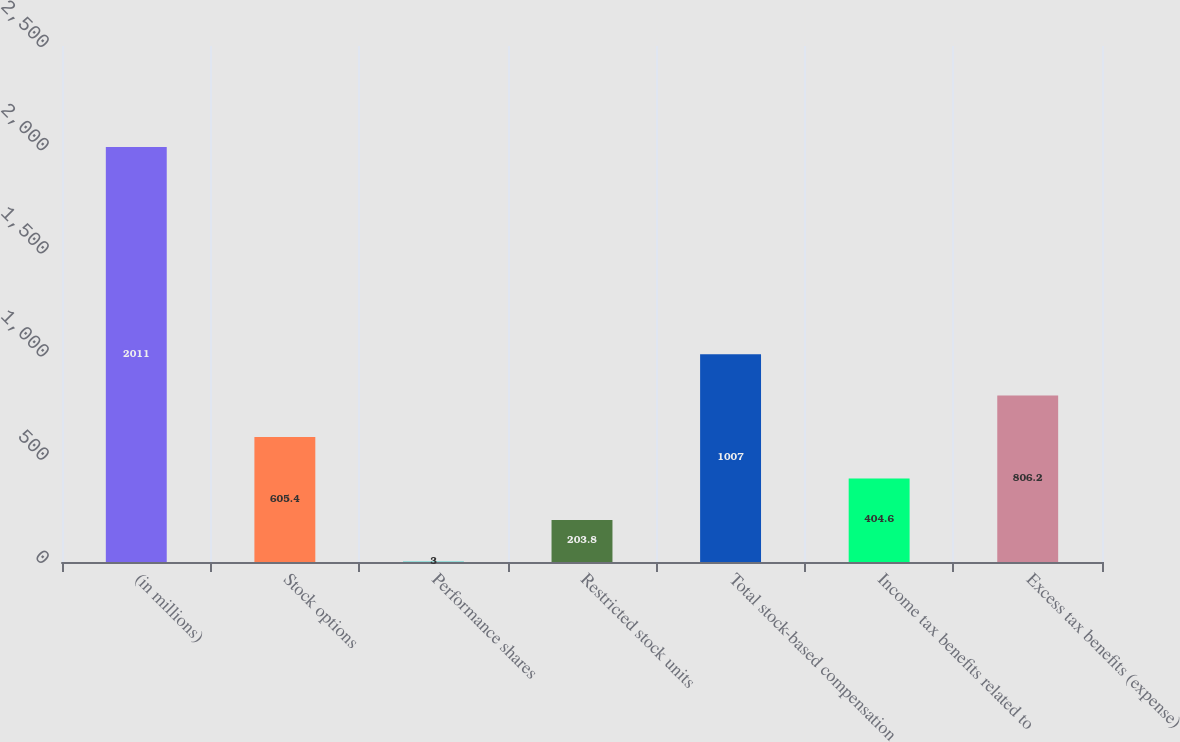<chart> <loc_0><loc_0><loc_500><loc_500><bar_chart><fcel>(in millions)<fcel>Stock options<fcel>Performance shares<fcel>Restricted stock units<fcel>Total stock-based compensation<fcel>Income tax benefits related to<fcel>Excess tax benefits (expense)<nl><fcel>2011<fcel>605.4<fcel>3<fcel>203.8<fcel>1007<fcel>404.6<fcel>806.2<nl></chart> 